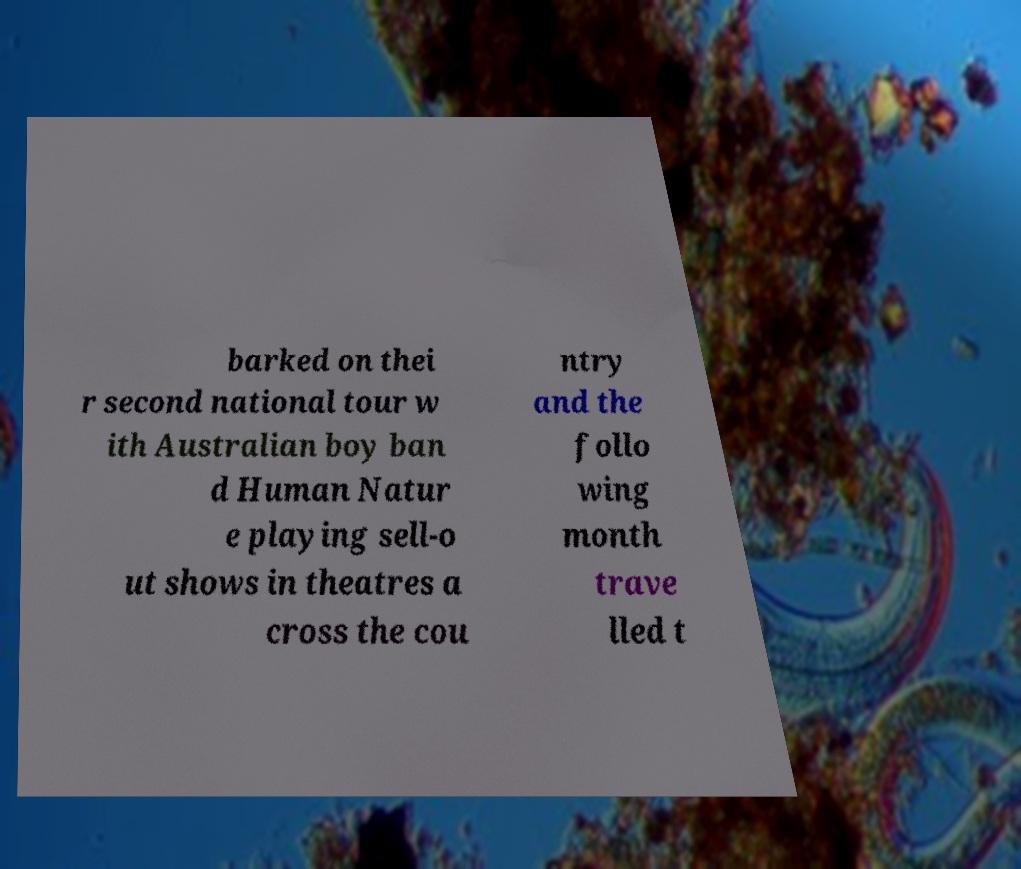I need the written content from this picture converted into text. Can you do that? barked on thei r second national tour w ith Australian boy ban d Human Natur e playing sell-o ut shows in theatres a cross the cou ntry and the follo wing month trave lled t 